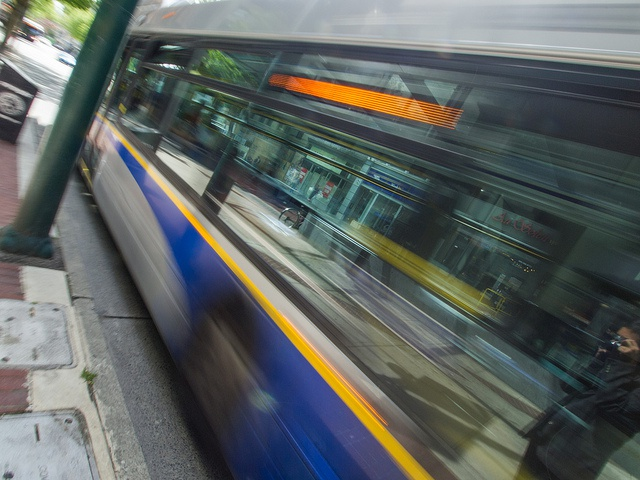Describe the objects in this image and their specific colors. I can see bus in lightgray, black, gray, darkgray, and purple tones and people in lightgray, black, gray, darkgreen, and purple tones in this image. 